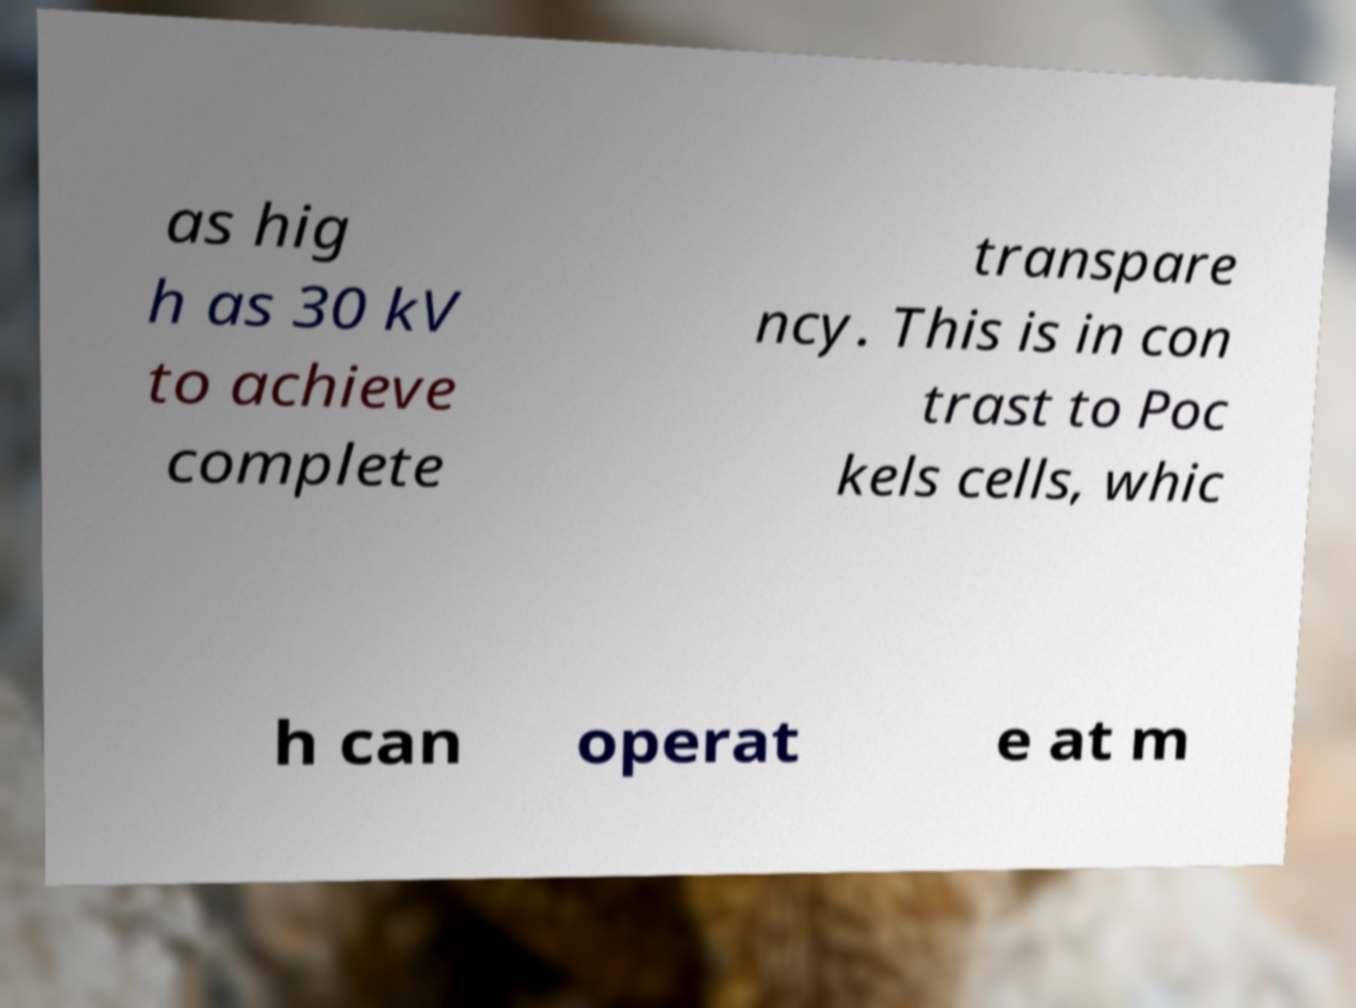There's text embedded in this image that I need extracted. Can you transcribe it verbatim? as hig h as 30 kV to achieve complete transpare ncy. This is in con trast to Poc kels cells, whic h can operat e at m 